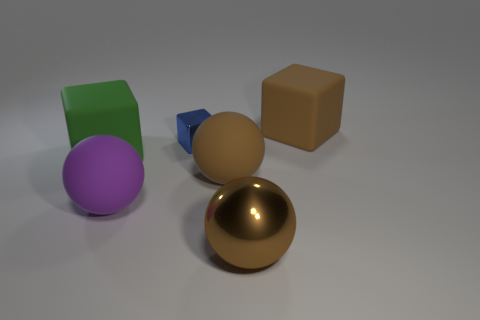Subtract 1 balls. How many balls are left? 2 Add 1 small brown metal blocks. How many objects exist? 7 Subtract all small brown things. Subtract all tiny things. How many objects are left? 5 Add 1 large rubber objects. How many large rubber objects are left? 5 Add 2 large cubes. How many large cubes exist? 4 Subtract 0 purple cylinders. How many objects are left? 6 